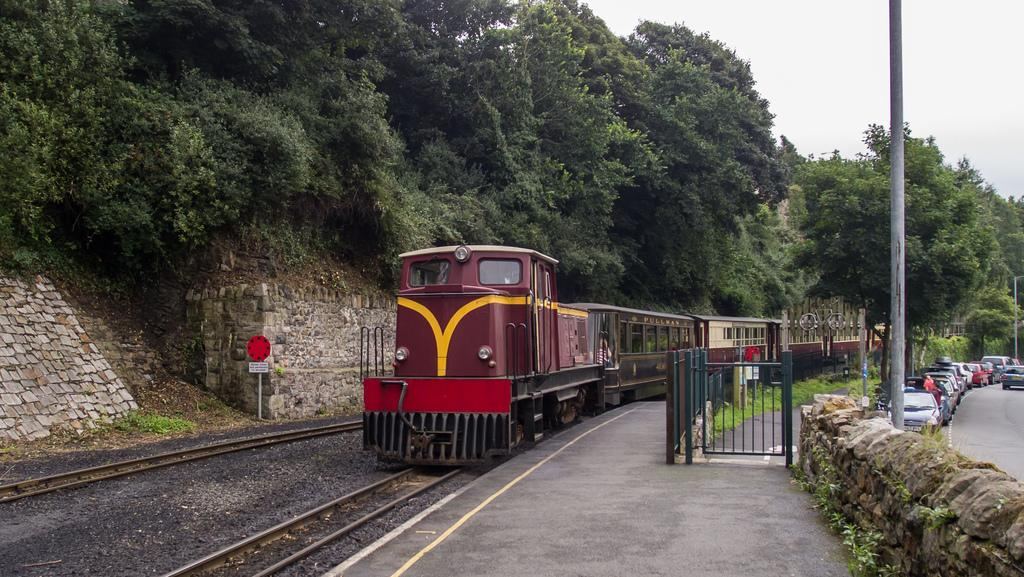What is the main subject of the image? The main subject of the image is a train on the track. What can be seen in the background of the image? There are trees in the image. What else is present in the image besides the train? There are vehicles on the road and a pole in the image. Can you see a jellyfish swimming in the image? No, there are no jellyfish present in the image. 